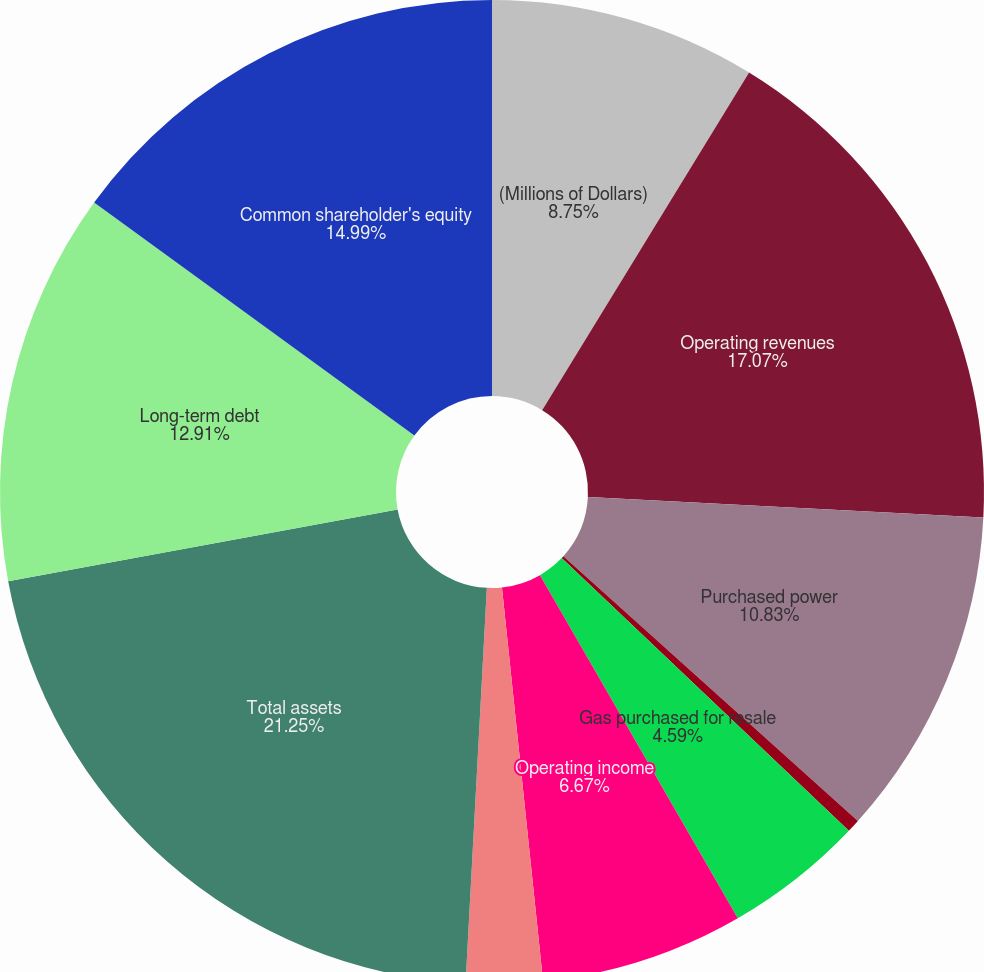Convert chart to OTSL. <chart><loc_0><loc_0><loc_500><loc_500><pie_chart><fcel>(Millions of Dollars)<fcel>Operating revenues<fcel>Purchased power<fcel>Fuel<fcel>Gas purchased for resale<fcel>Operating income<fcel>Net income for common stock<fcel>Total assets<fcel>Long-term debt<fcel>Common shareholder's equity<nl><fcel>8.75%<fcel>17.07%<fcel>10.83%<fcel>0.43%<fcel>4.59%<fcel>6.67%<fcel>2.51%<fcel>21.24%<fcel>12.91%<fcel>14.99%<nl></chart> 